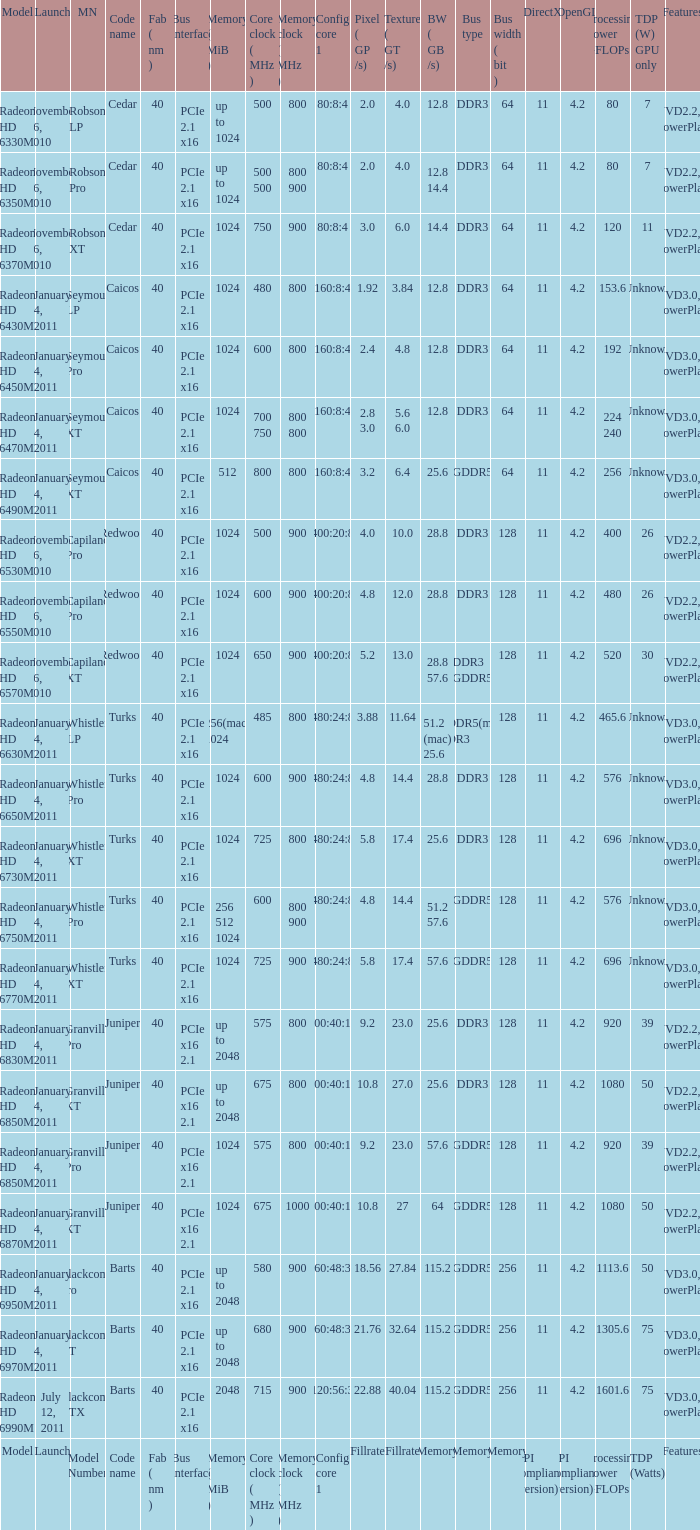What is every code name for the model Radeon HD 6650m? Turks. 